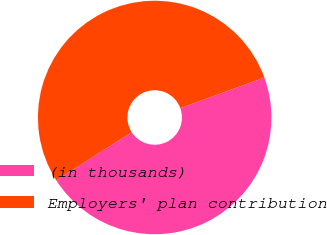<chart> <loc_0><loc_0><loc_500><loc_500><pie_chart><fcel>(in thousands)<fcel>Employers' plan contribution<nl><fcel>46.51%<fcel>53.49%<nl></chart> 